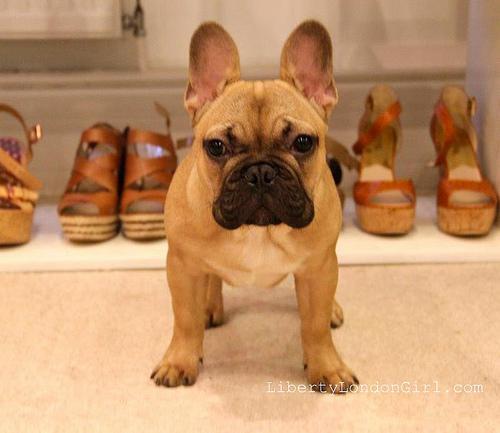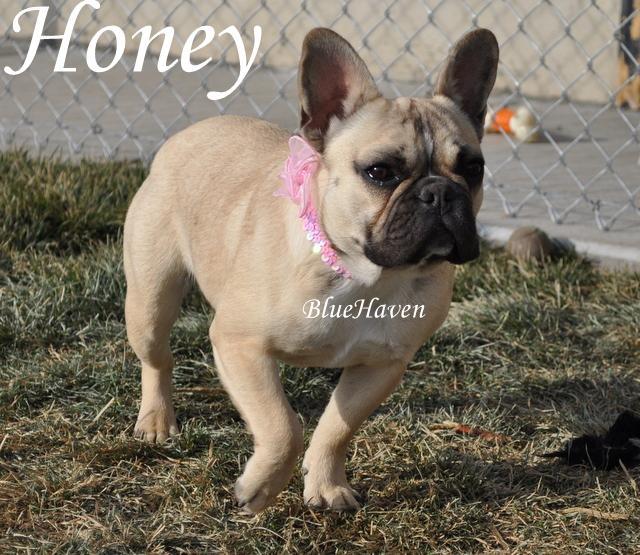The first image is the image on the left, the second image is the image on the right. Evaluate the accuracy of this statement regarding the images: "Each image includes one buff-beige bulldog puppy, and the puppy on the left is sitting on fabric, while the puppy on the right is standing on all fours.". Is it true? Answer yes or no. No. The first image is the image on the left, the second image is the image on the right. Evaluate the accuracy of this statement regarding the images: "None of the dogs pictured are wearing collars.". Is it true? Answer yes or no. No. 